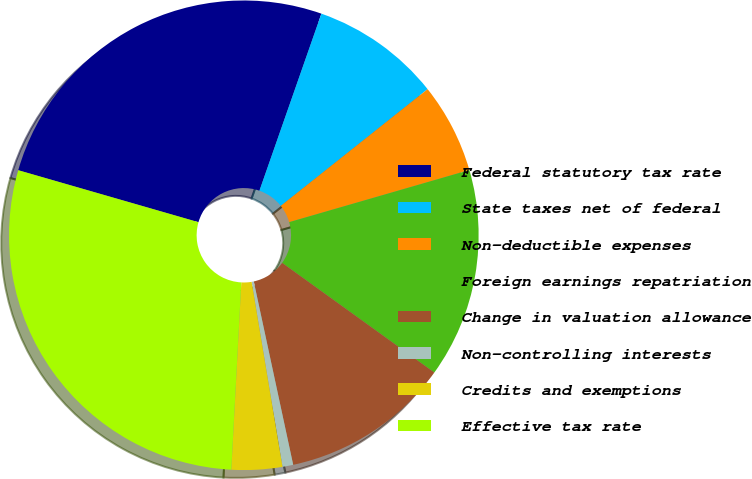Convert chart to OTSL. <chart><loc_0><loc_0><loc_500><loc_500><pie_chart><fcel>Federal statutory tax rate<fcel>State taxes net of federal<fcel>Non-deductible expenses<fcel>Foreign earnings repatriation<fcel>Change in valuation allowance<fcel>Non-controlling interests<fcel>Credits and exemptions<fcel>Effective tax rate<nl><fcel>25.89%<fcel>8.95%<fcel>6.21%<fcel>14.42%<fcel>11.69%<fcel>0.74%<fcel>3.48%<fcel>28.62%<nl></chart> 